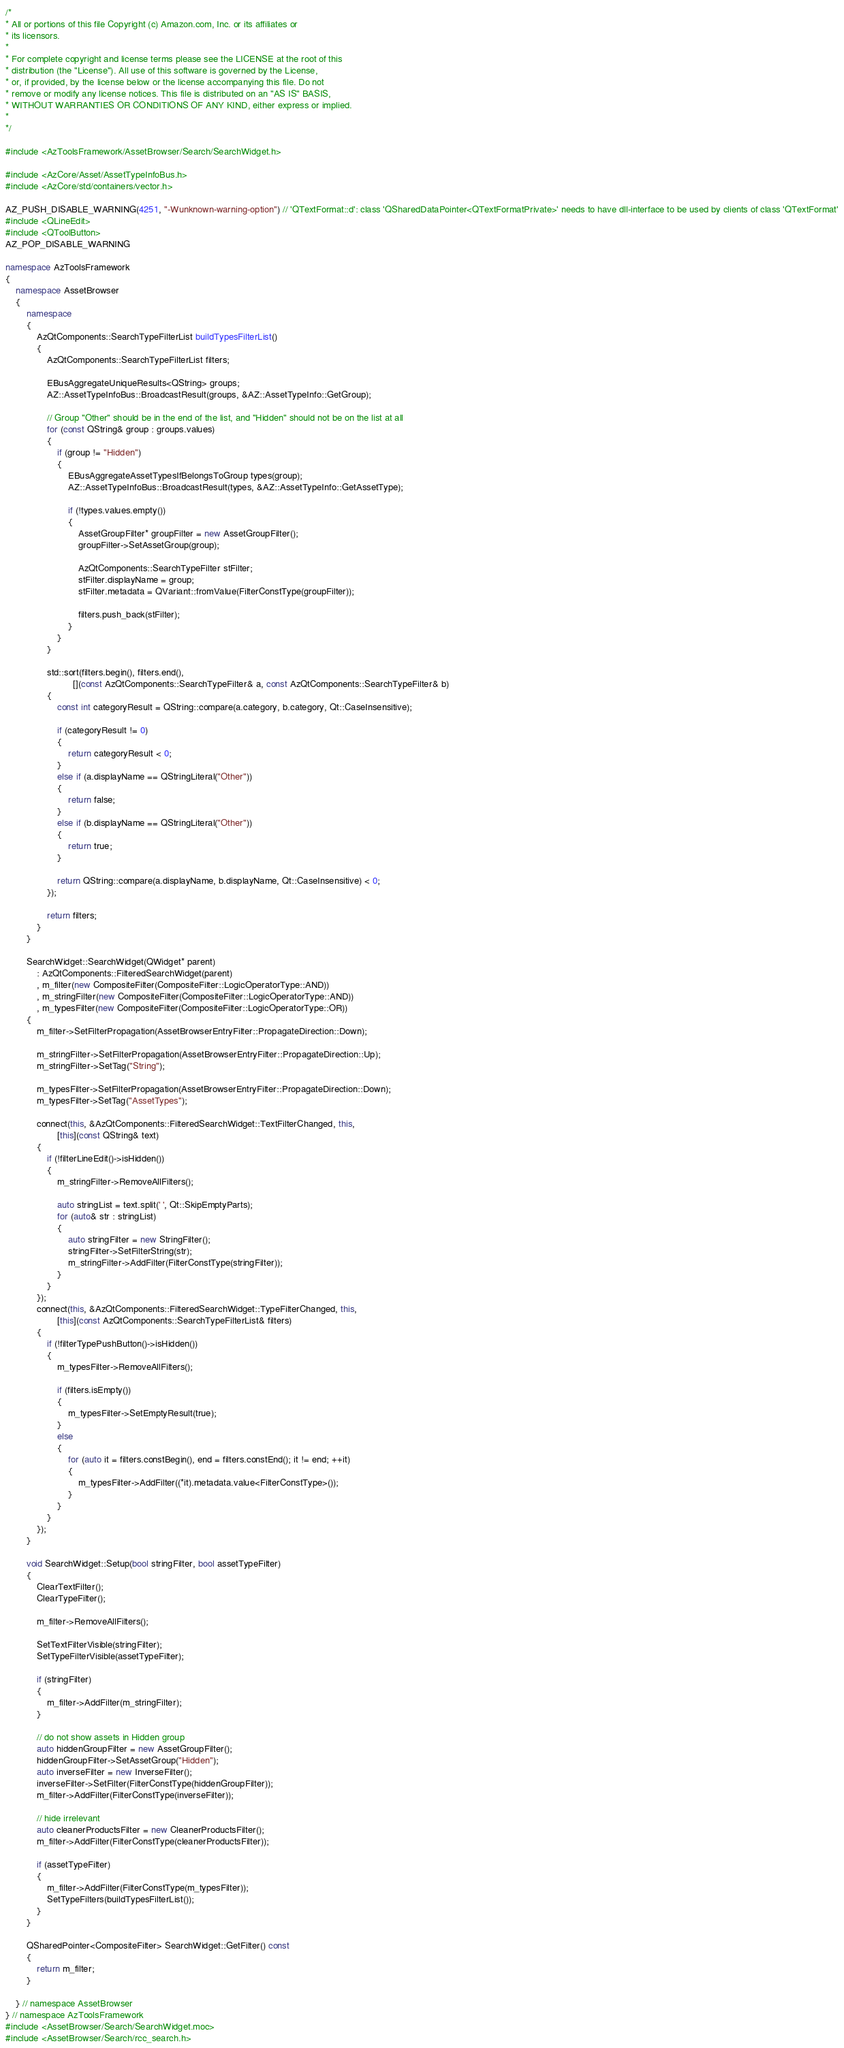Convert code to text. <code><loc_0><loc_0><loc_500><loc_500><_C++_>/*
* All or portions of this file Copyright (c) Amazon.com, Inc. or its affiliates or
* its licensors.
*
* For complete copyright and license terms please see the LICENSE at the root of this
* distribution (the "License"). All use of this software is governed by the License,
* or, if provided, by the license below or the license accompanying this file. Do not
* remove or modify any license notices. This file is distributed on an "AS IS" BASIS,
* WITHOUT WARRANTIES OR CONDITIONS OF ANY KIND, either express or implied.
*
*/

#include <AzToolsFramework/AssetBrowser/Search/SearchWidget.h>

#include <AzCore/Asset/AssetTypeInfoBus.h>
#include <AzCore/std/containers/vector.h>

AZ_PUSH_DISABLE_WARNING(4251, "-Wunknown-warning-option") // 'QTextFormat::d': class 'QSharedDataPointer<QTextFormatPrivate>' needs to have dll-interface to be used by clients of class 'QTextFormat'
#include <QLineEdit>
#include <QToolButton>
AZ_POP_DISABLE_WARNING

namespace AzToolsFramework
{
    namespace AssetBrowser
    {
        namespace
        {
            AzQtComponents::SearchTypeFilterList buildTypesFilterList()
            {
                AzQtComponents::SearchTypeFilterList filters;

                EBusAggregateUniqueResults<QString> groups;
                AZ::AssetTypeInfoBus::BroadcastResult(groups, &AZ::AssetTypeInfo::GetGroup);

                // Group "Other" should be in the end of the list, and "Hidden" should not be on the list at all
                for (const QString& group : groups.values)
                {
                    if (group != "Hidden")
                    {
                        EBusAggregateAssetTypesIfBelongsToGroup types(group);
                        AZ::AssetTypeInfoBus::BroadcastResult(types, &AZ::AssetTypeInfo::GetAssetType);

                        if (!types.values.empty())
                        {
                            AssetGroupFilter* groupFilter = new AssetGroupFilter();
                            groupFilter->SetAssetGroup(group);

                            AzQtComponents::SearchTypeFilter stFilter;
                            stFilter.displayName = group;
                            stFilter.metadata = QVariant::fromValue(FilterConstType(groupFilter));

                            filters.push_back(stFilter);
                        }
                    }
                }

                std::sort(filters.begin(), filters.end(),
                          [](const AzQtComponents::SearchTypeFilter& a, const AzQtComponents::SearchTypeFilter& b)
                {
                    const int categoryResult = QString::compare(a.category, b.category, Qt::CaseInsensitive);

                    if (categoryResult != 0)
                    {
                        return categoryResult < 0;
                    }
                    else if (a.displayName == QStringLiteral("Other"))
                    {
                        return false;
                    }
                    else if (b.displayName == QStringLiteral("Other"))
                    {
                        return true;
                    }

                    return QString::compare(a.displayName, b.displayName, Qt::CaseInsensitive) < 0;
                });

                return filters;
            }
        }

        SearchWidget::SearchWidget(QWidget* parent)
            : AzQtComponents::FilteredSearchWidget(parent)
            , m_filter(new CompositeFilter(CompositeFilter::LogicOperatorType::AND))
            , m_stringFilter(new CompositeFilter(CompositeFilter::LogicOperatorType::AND))
            , m_typesFilter(new CompositeFilter(CompositeFilter::LogicOperatorType::OR))
        {
            m_filter->SetFilterPropagation(AssetBrowserEntryFilter::PropagateDirection::Down);

            m_stringFilter->SetFilterPropagation(AssetBrowserEntryFilter::PropagateDirection::Up);
            m_stringFilter->SetTag("String");

            m_typesFilter->SetFilterPropagation(AssetBrowserEntryFilter::PropagateDirection::Down);
            m_typesFilter->SetTag("AssetTypes");

            connect(this, &AzQtComponents::FilteredSearchWidget::TextFilterChanged, this,
                    [this](const QString& text)
            {
                if (!filterLineEdit()->isHidden())
                {
                    m_stringFilter->RemoveAllFilters();

                    auto stringList = text.split(' ', Qt::SkipEmptyParts);
                    for (auto& str : stringList)
                    {
                        auto stringFilter = new StringFilter();
                        stringFilter->SetFilterString(str);
                        m_stringFilter->AddFilter(FilterConstType(stringFilter));
                    }
                }
            });
            connect(this, &AzQtComponents::FilteredSearchWidget::TypeFilterChanged, this,
                    [this](const AzQtComponents::SearchTypeFilterList& filters)
            {
                if (!filterTypePushButton()->isHidden())
                {
                    m_typesFilter->RemoveAllFilters();

                    if (filters.isEmpty())
                    {
                        m_typesFilter->SetEmptyResult(true);
                    }
                    else
                    {
                        for (auto it = filters.constBegin(), end = filters.constEnd(); it != end; ++it)
                        {
                            m_typesFilter->AddFilter((*it).metadata.value<FilterConstType>());
                        }
                    }
                }
            });
        }

        void SearchWidget::Setup(bool stringFilter, bool assetTypeFilter)
        {
            ClearTextFilter();
            ClearTypeFilter();

            m_filter->RemoveAllFilters();

            SetTextFilterVisible(stringFilter);
            SetTypeFilterVisible(assetTypeFilter);

            if (stringFilter)
            {
                m_filter->AddFilter(m_stringFilter);
            }

            // do not show assets in Hidden group
            auto hiddenGroupFilter = new AssetGroupFilter();
            hiddenGroupFilter->SetAssetGroup("Hidden");
            auto inverseFilter = new InverseFilter();
            inverseFilter->SetFilter(FilterConstType(hiddenGroupFilter));
            m_filter->AddFilter(FilterConstType(inverseFilter));

            // hide irrelevant
            auto cleanerProductsFilter = new CleanerProductsFilter();
            m_filter->AddFilter(FilterConstType(cleanerProductsFilter));

            if (assetTypeFilter)
            {
                m_filter->AddFilter(FilterConstType(m_typesFilter));
                SetTypeFilters(buildTypesFilterList());
            }
        }

        QSharedPointer<CompositeFilter> SearchWidget::GetFilter() const
        {
            return m_filter;
        }

    } // namespace AssetBrowser
} // namespace AzToolsFramework
#include <AssetBrowser/Search/SearchWidget.moc>
#include <AssetBrowser/Search/rcc_search.h>

</code> 